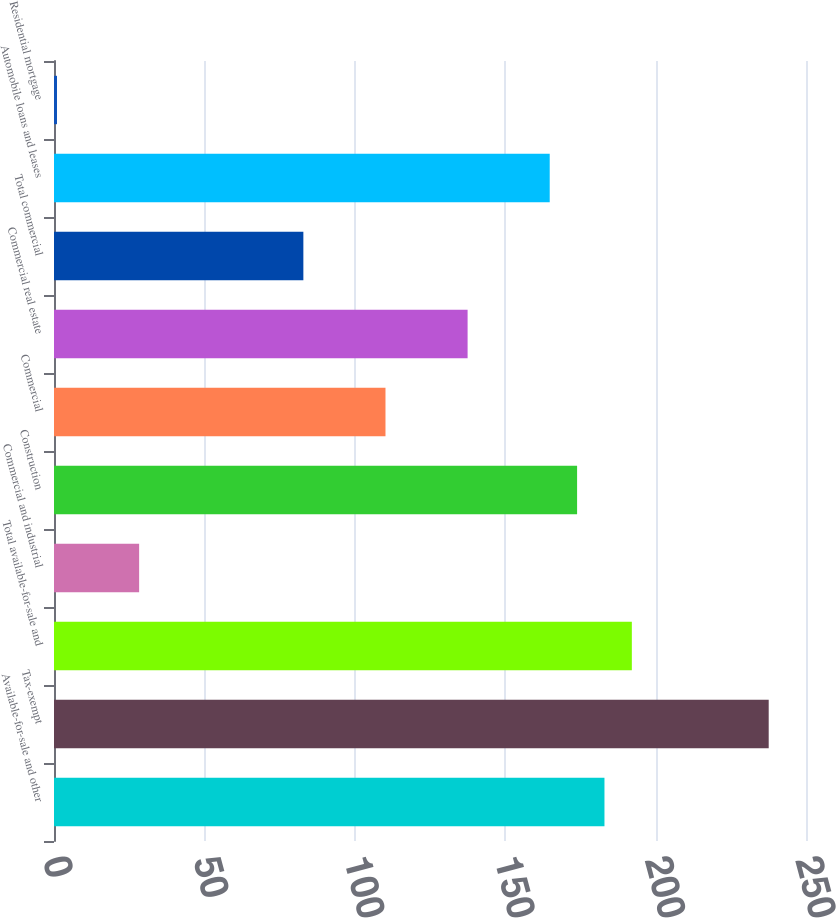Convert chart to OTSL. <chart><loc_0><loc_0><loc_500><loc_500><bar_chart><fcel>Available-for-sale and other<fcel>Tax-exempt<fcel>Total available-for-sale and<fcel>Commercial and industrial<fcel>Construction<fcel>Commercial<fcel>Commercial real estate<fcel>Total commercial<fcel>Automobile loans and leases<fcel>Residential mortgage<nl><fcel>183<fcel>237.6<fcel>192.1<fcel>28.3<fcel>173.9<fcel>110.2<fcel>137.5<fcel>82.9<fcel>164.8<fcel>1<nl></chart> 